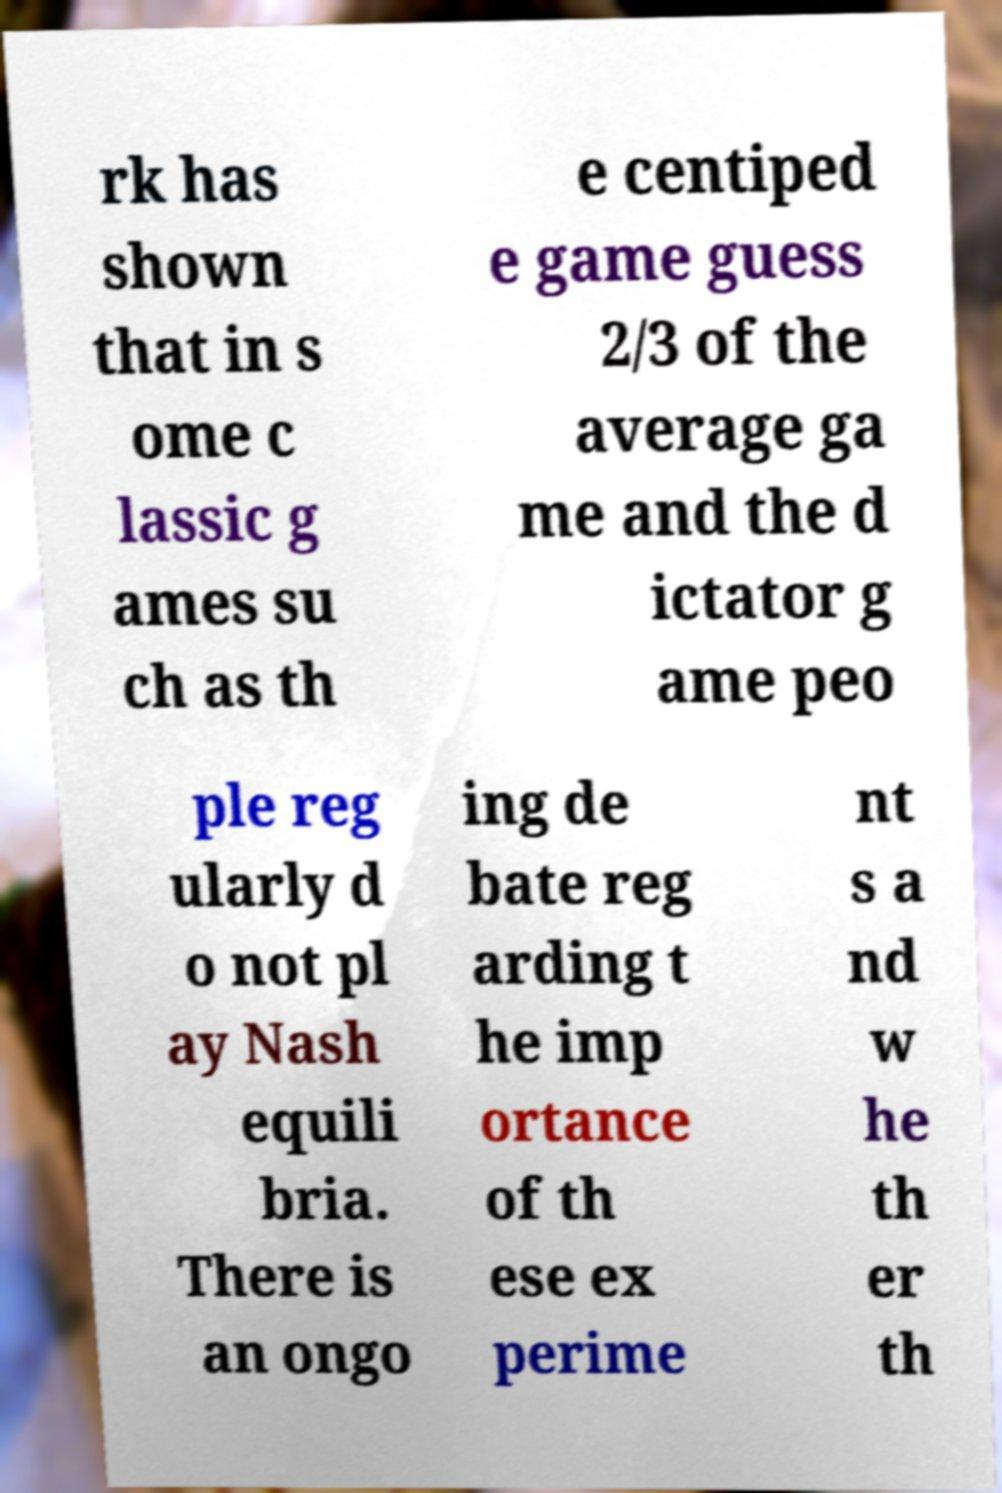I need the written content from this picture converted into text. Can you do that? rk has shown that in s ome c lassic g ames su ch as th e centiped e game guess 2/3 of the average ga me and the d ictator g ame peo ple reg ularly d o not pl ay Nash equili bria. There is an ongo ing de bate reg arding t he imp ortance of th ese ex perime nt s a nd w he th er th 